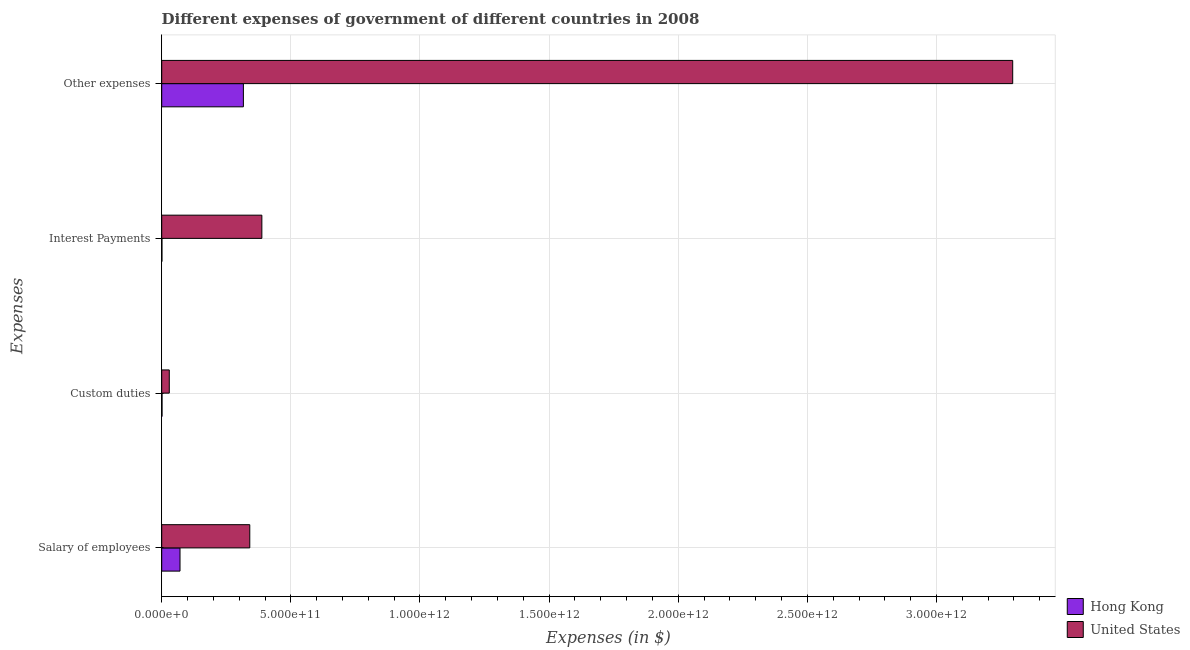How many different coloured bars are there?
Your response must be concise. 2. How many groups of bars are there?
Your response must be concise. 4. Are the number of bars per tick equal to the number of legend labels?
Offer a very short reply. Yes. What is the label of the 1st group of bars from the top?
Keep it short and to the point. Other expenses. What is the amount spent on salary of employees in Hong Kong?
Provide a short and direct response. 7.09e+1. Across all countries, what is the maximum amount spent on salary of employees?
Provide a succinct answer. 3.41e+11. Across all countries, what is the minimum amount spent on custom duties?
Your response must be concise. 1.26e+09. In which country was the amount spent on other expenses maximum?
Your answer should be very brief. United States. In which country was the amount spent on salary of employees minimum?
Make the answer very short. Hong Kong. What is the total amount spent on interest payments in the graph?
Your answer should be very brief. 3.89e+11. What is the difference between the amount spent on other expenses in United States and that in Hong Kong?
Offer a very short reply. 2.98e+12. What is the difference between the amount spent on other expenses in Hong Kong and the amount spent on custom duties in United States?
Ensure brevity in your answer.  2.87e+11. What is the average amount spent on custom duties per country?
Offer a very short reply. 1.53e+1. What is the difference between the amount spent on custom duties and amount spent on salary of employees in United States?
Ensure brevity in your answer.  -3.12e+11. What is the ratio of the amount spent on salary of employees in United States to that in Hong Kong?
Your answer should be very brief. 4.81. Is the amount spent on custom duties in United States less than that in Hong Kong?
Provide a succinct answer. No. What is the difference between the highest and the second highest amount spent on salary of employees?
Keep it short and to the point. 2.70e+11. What is the difference between the highest and the lowest amount spent on other expenses?
Your answer should be compact. 2.98e+12. In how many countries, is the amount spent on custom duties greater than the average amount spent on custom duties taken over all countries?
Ensure brevity in your answer.  1. Is the sum of the amount spent on custom duties in United States and Hong Kong greater than the maximum amount spent on other expenses across all countries?
Your answer should be compact. No. What does the 2nd bar from the top in Salary of employees represents?
Provide a succinct answer. Hong Kong. What does the 1st bar from the bottom in Interest Payments represents?
Your answer should be compact. Hong Kong. Is it the case that in every country, the sum of the amount spent on salary of employees and amount spent on custom duties is greater than the amount spent on interest payments?
Your answer should be compact. No. Are all the bars in the graph horizontal?
Give a very brief answer. Yes. What is the difference between two consecutive major ticks on the X-axis?
Keep it short and to the point. 5.00e+11. Does the graph contain any zero values?
Your answer should be very brief. No. Where does the legend appear in the graph?
Give a very brief answer. Bottom right. How many legend labels are there?
Provide a short and direct response. 2. How are the legend labels stacked?
Your answer should be very brief. Vertical. What is the title of the graph?
Your answer should be very brief. Different expenses of government of different countries in 2008. What is the label or title of the X-axis?
Offer a very short reply. Expenses (in $). What is the label or title of the Y-axis?
Provide a short and direct response. Expenses. What is the Expenses (in $) in Hong Kong in Salary of employees?
Ensure brevity in your answer.  7.09e+1. What is the Expenses (in $) of United States in Salary of employees?
Offer a very short reply. 3.41e+11. What is the Expenses (in $) of Hong Kong in Custom duties?
Offer a terse response. 1.26e+09. What is the Expenses (in $) in United States in Custom duties?
Make the answer very short. 2.93e+1. What is the Expenses (in $) of Hong Kong in Interest Payments?
Provide a short and direct response. 9.01e+08. What is the Expenses (in $) of United States in Interest Payments?
Offer a very short reply. 3.88e+11. What is the Expenses (in $) of Hong Kong in Other expenses?
Your response must be concise. 3.16e+11. What is the Expenses (in $) of United States in Other expenses?
Offer a very short reply. 3.30e+12. Across all Expenses, what is the maximum Expenses (in $) in Hong Kong?
Provide a succinct answer. 3.16e+11. Across all Expenses, what is the maximum Expenses (in $) of United States?
Ensure brevity in your answer.  3.30e+12. Across all Expenses, what is the minimum Expenses (in $) in Hong Kong?
Make the answer very short. 9.01e+08. Across all Expenses, what is the minimum Expenses (in $) in United States?
Your answer should be very brief. 2.93e+1. What is the total Expenses (in $) in Hong Kong in the graph?
Make the answer very short. 3.89e+11. What is the total Expenses (in $) of United States in the graph?
Make the answer very short. 4.05e+12. What is the difference between the Expenses (in $) in Hong Kong in Salary of employees and that in Custom duties?
Ensure brevity in your answer.  6.96e+1. What is the difference between the Expenses (in $) of United States in Salary of employees and that in Custom duties?
Offer a very short reply. 3.12e+11. What is the difference between the Expenses (in $) of Hong Kong in Salary of employees and that in Interest Payments?
Provide a short and direct response. 7.00e+1. What is the difference between the Expenses (in $) in United States in Salary of employees and that in Interest Payments?
Provide a short and direct response. -4.68e+1. What is the difference between the Expenses (in $) of Hong Kong in Salary of employees and that in Other expenses?
Offer a terse response. -2.45e+11. What is the difference between the Expenses (in $) of United States in Salary of employees and that in Other expenses?
Your answer should be compact. -2.95e+12. What is the difference between the Expenses (in $) in Hong Kong in Custom duties and that in Interest Payments?
Your response must be concise. 3.62e+08. What is the difference between the Expenses (in $) of United States in Custom duties and that in Interest Payments?
Provide a short and direct response. -3.58e+11. What is the difference between the Expenses (in $) in Hong Kong in Custom duties and that in Other expenses?
Your response must be concise. -3.15e+11. What is the difference between the Expenses (in $) in United States in Custom duties and that in Other expenses?
Make the answer very short. -3.27e+12. What is the difference between the Expenses (in $) of Hong Kong in Interest Payments and that in Other expenses?
Make the answer very short. -3.15e+11. What is the difference between the Expenses (in $) of United States in Interest Payments and that in Other expenses?
Your answer should be very brief. -2.91e+12. What is the difference between the Expenses (in $) in Hong Kong in Salary of employees and the Expenses (in $) in United States in Custom duties?
Ensure brevity in your answer.  4.16e+1. What is the difference between the Expenses (in $) in Hong Kong in Salary of employees and the Expenses (in $) in United States in Interest Payments?
Ensure brevity in your answer.  -3.17e+11. What is the difference between the Expenses (in $) of Hong Kong in Salary of employees and the Expenses (in $) of United States in Other expenses?
Your answer should be compact. -3.22e+12. What is the difference between the Expenses (in $) of Hong Kong in Custom duties and the Expenses (in $) of United States in Interest Payments?
Ensure brevity in your answer.  -3.87e+11. What is the difference between the Expenses (in $) of Hong Kong in Custom duties and the Expenses (in $) of United States in Other expenses?
Your response must be concise. -3.29e+12. What is the difference between the Expenses (in $) in Hong Kong in Interest Payments and the Expenses (in $) in United States in Other expenses?
Give a very brief answer. -3.29e+12. What is the average Expenses (in $) of Hong Kong per Expenses?
Provide a short and direct response. 9.73e+1. What is the average Expenses (in $) in United States per Expenses?
Provide a short and direct response. 1.01e+12. What is the difference between the Expenses (in $) in Hong Kong and Expenses (in $) in United States in Salary of employees?
Provide a succinct answer. -2.70e+11. What is the difference between the Expenses (in $) in Hong Kong and Expenses (in $) in United States in Custom duties?
Offer a terse response. -2.80e+1. What is the difference between the Expenses (in $) of Hong Kong and Expenses (in $) of United States in Interest Payments?
Your answer should be compact. -3.87e+11. What is the difference between the Expenses (in $) of Hong Kong and Expenses (in $) of United States in Other expenses?
Provide a succinct answer. -2.98e+12. What is the ratio of the Expenses (in $) of Hong Kong in Salary of employees to that in Custom duties?
Provide a succinct answer. 56.11. What is the ratio of the Expenses (in $) of United States in Salary of employees to that in Custom duties?
Provide a succinct answer. 11.64. What is the ratio of the Expenses (in $) in Hong Kong in Salary of employees to that in Interest Payments?
Make the answer very short. 78.65. What is the ratio of the Expenses (in $) in United States in Salary of employees to that in Interest Payments?
Provide a short and direct response. 0.88. What is the ratio of the Expenses (in $) of Hong Kong in Salary of employees to that in Other expenses?
Ensure brevity in your answer.  0.22. What is the ratio of the Expenses (in $) in United States in Salary of employees to that in Other expenses?
Your answer should be very brief. 0.1. What is the ratio of the Expenses (in $) of Hong Kong in Custom duties to that in Interest Payments?
Give a very brief answer. 1.4. What is the ratio of the Expenses (in $) in United States in Custom duties to that in Interest Payments?
Provide a short and direct response. 0.08. What is the ratio of the Expenses (in $) of Hong Kong in Custom duties to that in Other expenses?
Offer a terse response. 0. What is the ratio of the Expenses (in $) of United States in Custom duties to that in Other expenses?
Offer a very short reply. 0.01. What is the ratio of the Expenses (in $) in Hong Kong in Interest Payments to that in Other expenses?
Your answer should be compact. 0. What is the ratio of the Expenses (in $) in United States in Interest Payments to that in Other expenses?
Make the answer very short. 0.12. What is the difference between the highest and the second highest Expenses (in $) in Hong Kong?
Your answer should be compact. 2.45e+11. What is the difference between the highest and the second highest Expenses (in $) in United States?
Give a very brief answer. 2.91e+12. What is the difference between the highest and the lowest Expenses (in $) of Hong Kong?
Your response must be concise. 3.15e+11. What is the difference between the highest and the lowest Expenses (in $) of United States?
Your answer should be very brief. 3.27e+12. 